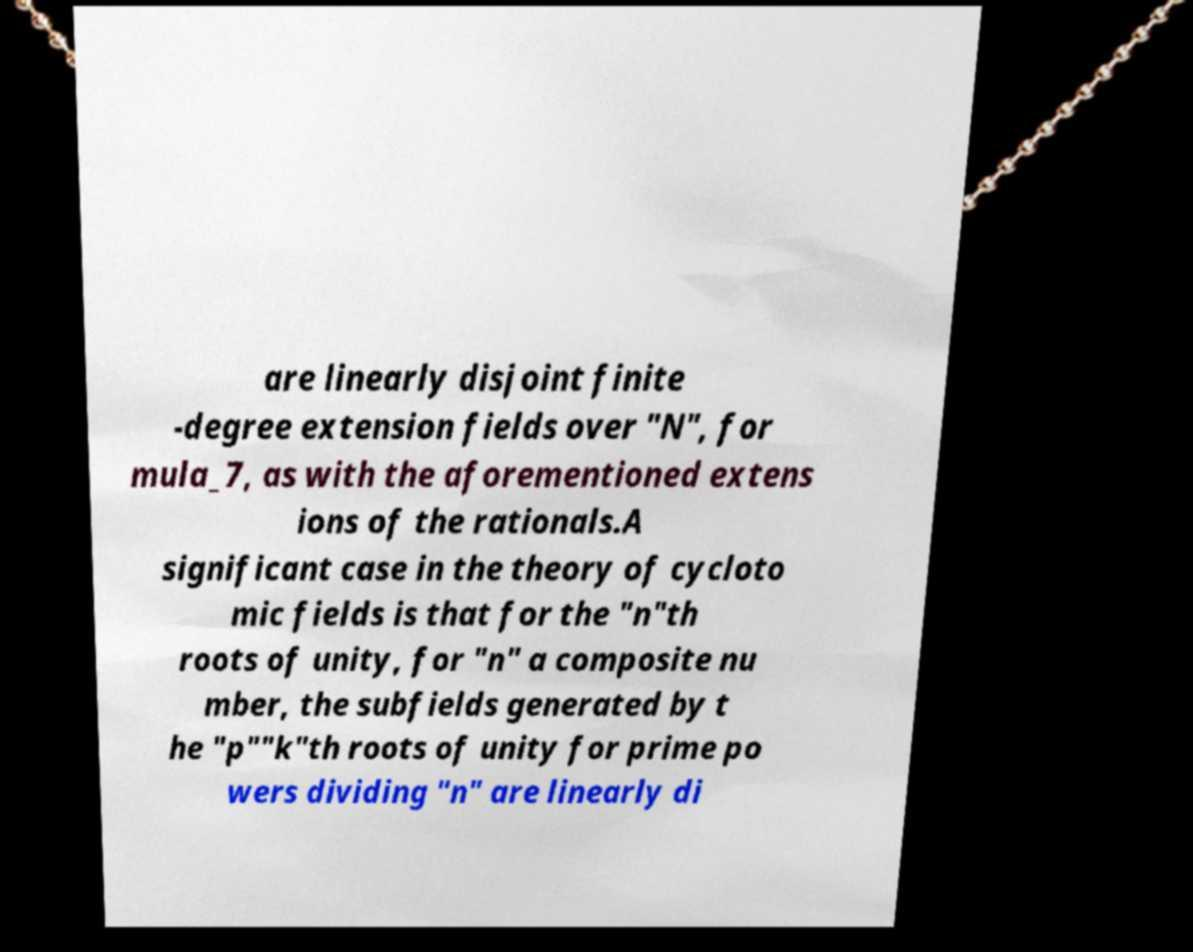Please read and relay the text visible in this image. What does it say? are linearly disjoint finite -degree extension fields over "N", for mula_7, as with the aforementioned extens ions of the rationals.A significant case in the theory of cycloto mic fields is that for the "n"th roots of unity, for "n" a composite nu mber, the subfields generated by t he "p""k"th roots of unity for prime po wers dividing "n" are linearly di 